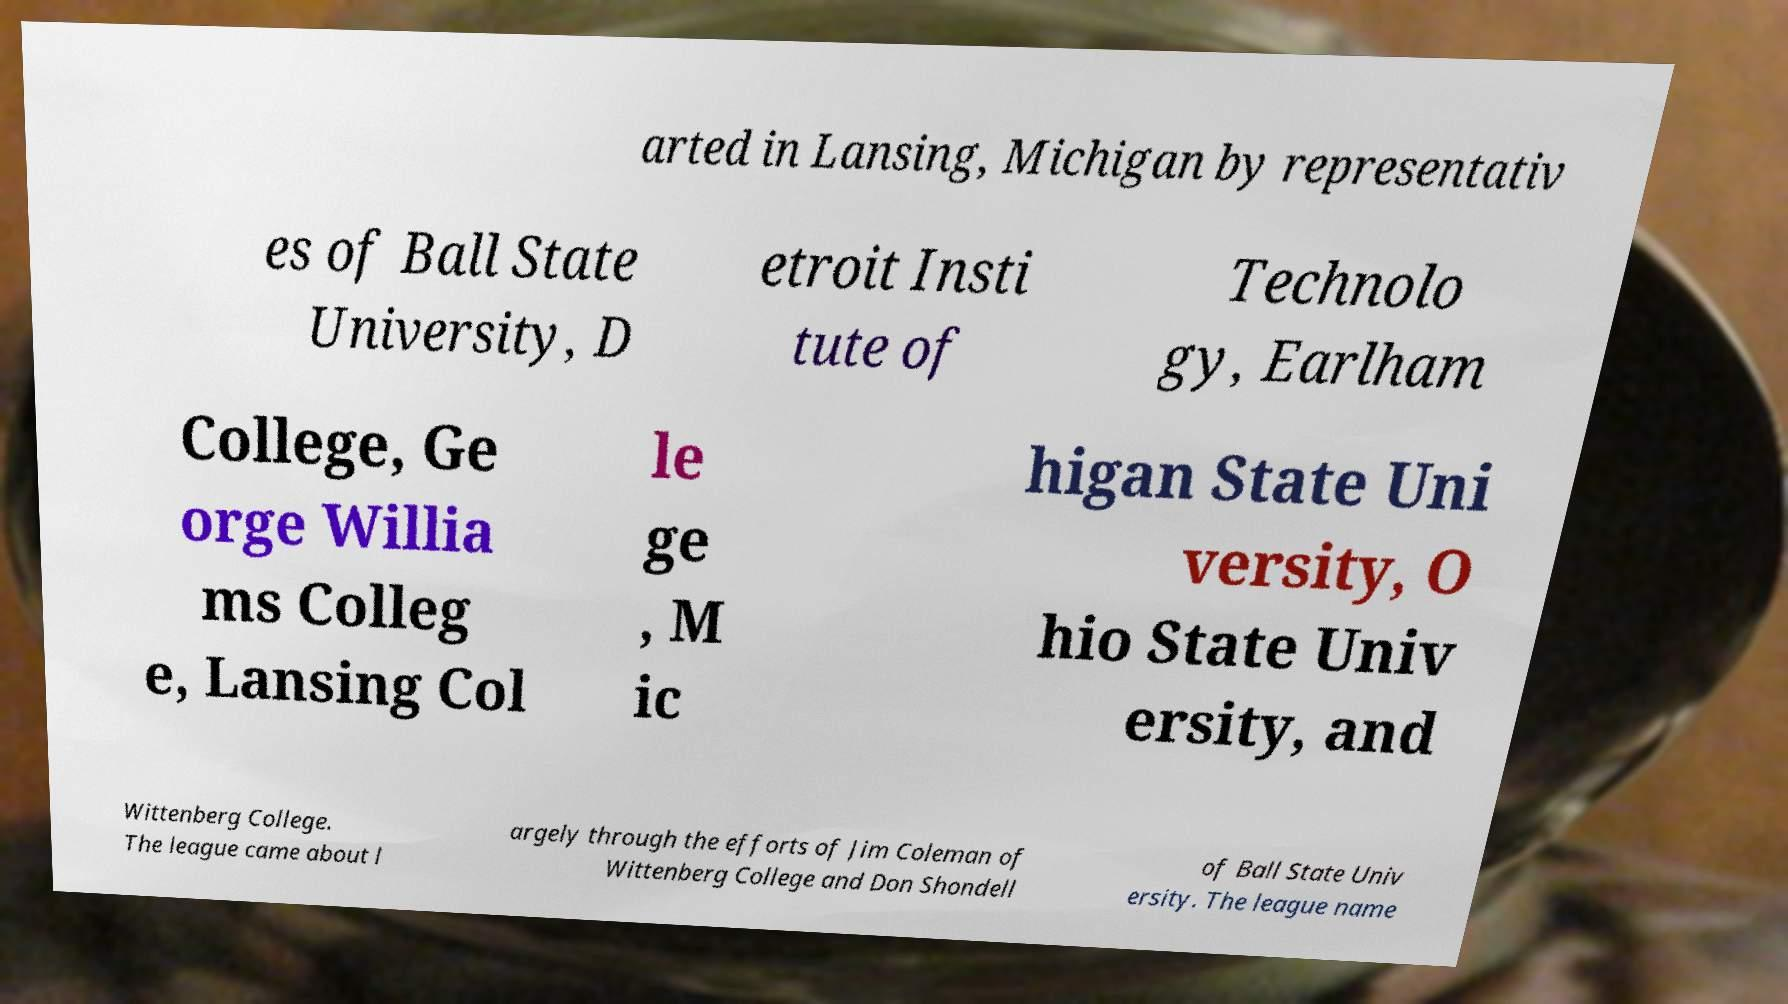For documentation purposes, I need the text within this image transcribed. Could you provide that? arted in Lansing, Michigan by representativ es of Ball State University, D etroit Insti tute of Technolo gy, Earlham College, Ge orge Willia ms Colleg e, Lansing Col le ge , M ic higan State Uni versity, O hio State Univ ersity, and Wittenberg College. The league came about l argely through the efforts of Jim Coleman of Wittenberg College and Don Shondell of Ball State Univ ersity. The league name 